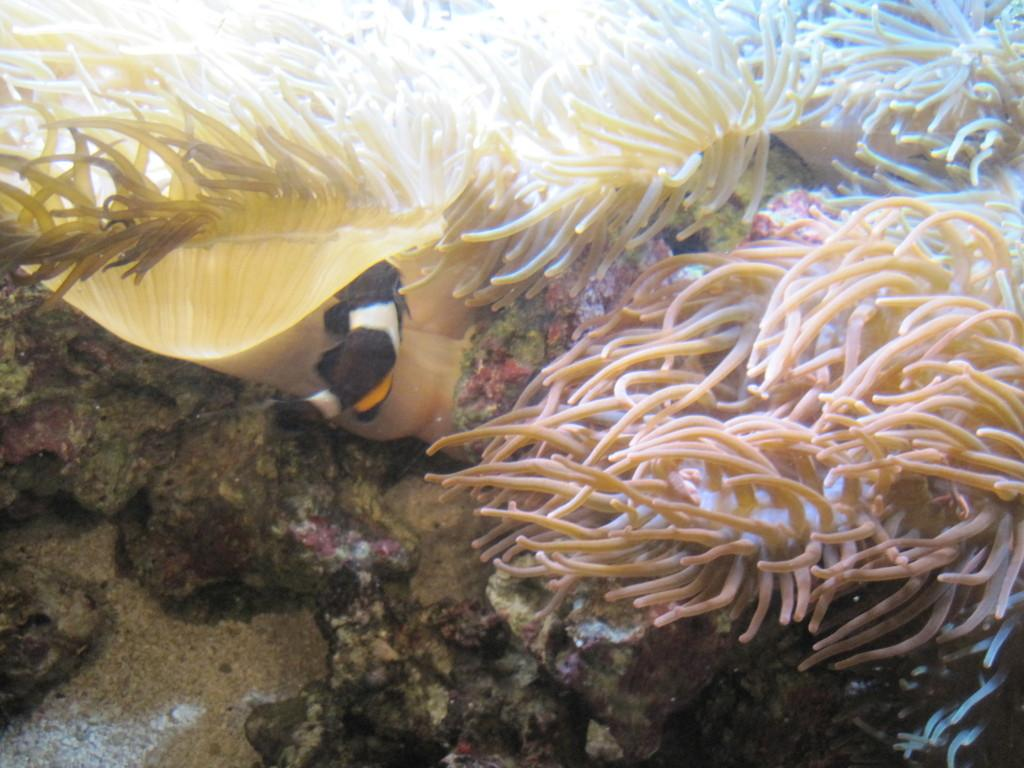What type of environment is shown in the image? The image depicts an underwater environment. Can you describe any specific features of the underwater environment? Unfortunately, the provided facts do not give any specific details about the underwater environment. Are there any living organisms visible in the image? The provided facts do not mention any living organisms in the image. What color is the crayon used to draw the underwater scene in the image? There is no crayon or drawing present in the image; it depicts a real underwater environment. How many casts are visible in the image? There are no casts present in the image. 